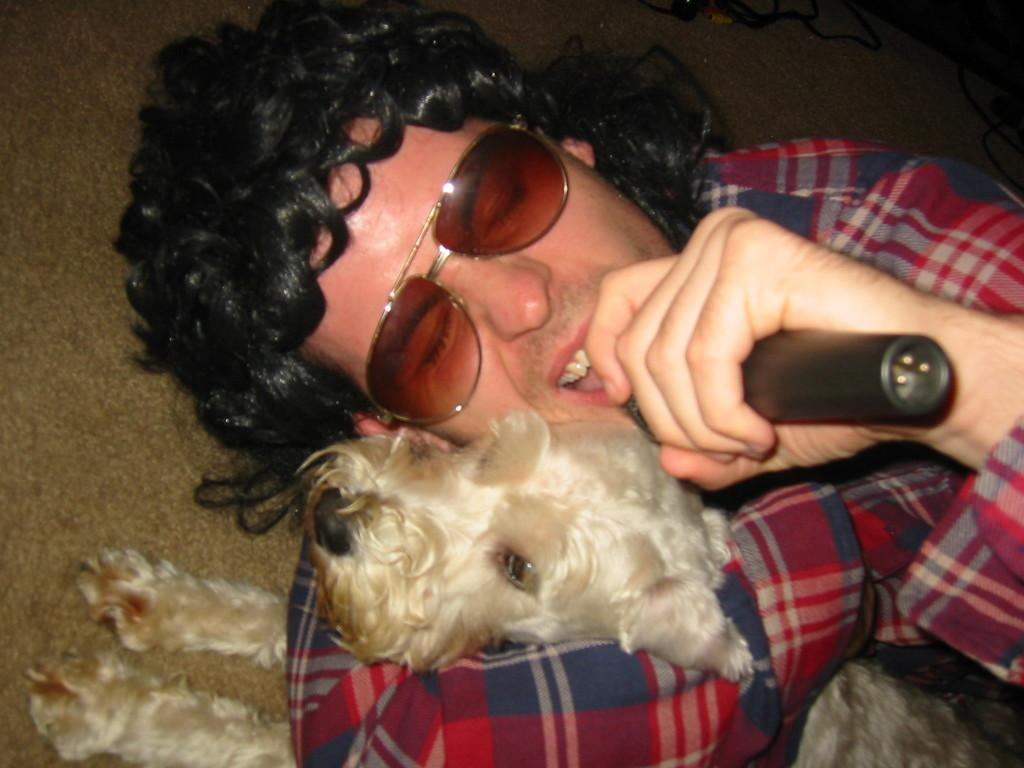What is the main subject in the middle of the image? There is a person in the middle of the image. What is the person wearing? The person is wearing goggles. What is the person holding? The person is holding a mic. Can you describe the dog in the image? The dog is on the left side of the image and is white in color. How does the dog help the person on their journey in the image? The image does not depict a journey, and there is no indication that the dog is assisting the person in any way. 